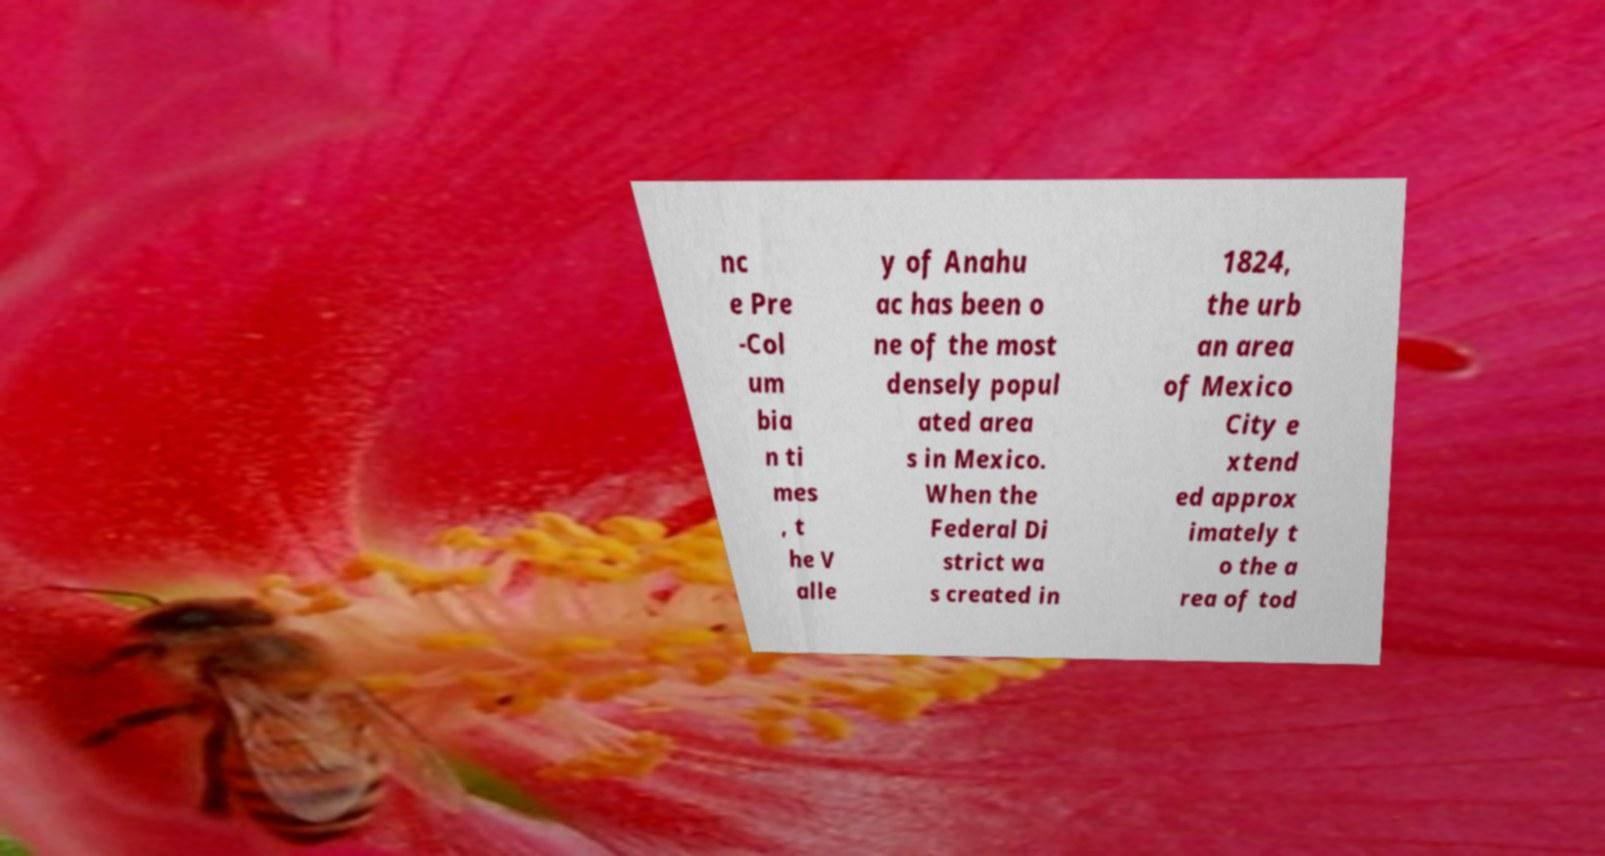Can you accurately transcribe the text from the provided image for me? nc e Pre -Col um bia n ti mes , t he V alle y of Anahu ac has been o ne of the most densely popul ated area s in Mexico. When the Federal Di strict wa s created in 1824, the urb an area of Mexico City e xtend ed approx imately t o the a rea of tod 